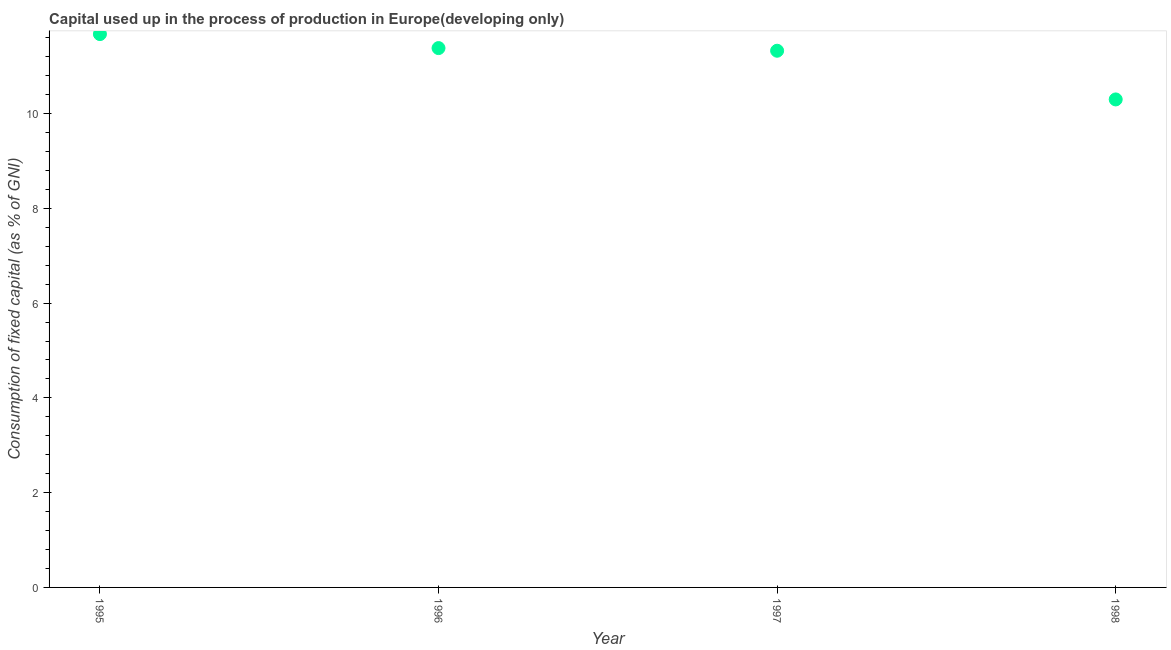What is the consumption of fixed capital in 1997?
Keep it short and to the point. 11.33. Across all years, what is the maximum consumption of fixed capital?
Your answer should be compact. 11.68. Across all years, what is the minimum consumption of fixed capital?
Ensure brevity in your answer.  10.3. What is the sum of the consumption of fixed capital?
Give a very brief answer. 44.68. What is the difference between the consumption of fixed capital in 1997 and 1998?
Provide a short and direct response. 1.03. What is the average consumption of fixed capital per year?
Make the answer very short. 11.17. What is the median consumption of fixed capital?
Your answer should be compact. 11.35. Do a majority of the years between 1996 and 1995 (inclusive) have consumption of fixed capital greater than 0.8 %?
Offer a very short reply. No. What is the ratio of the consumption of fixed capital in 1996 to that in 1997?
Give a very brief answer. 1. Is the consumption of fixed capital in 1995 less than that in 1997?
Offer a terse response. No. What is the difference between the highest and the second highest consumption of fixed capital?
Your answer should be very brief. 0.3. Is the sum of the consumption of fixed capital in 1997 and 1998 greater than the maximum consumption of fixed capital across all years?
Provide a short and direct response. Yes. What is the difference between the highest and the lowest consumption of fixed capital?
Your answer should be compact. 1.38. In how many years, is the consumption of fixed capital greater than the average consumption of fixed capital taken over all years?
Your answer should be very brief. 3. Does the consumption of fixed capital monotonically increase over the years?
Your answer should be compact. No. Does the graph contain any zero values?
Provide a succinct answer. No. What is the title of the graph?
Make the answer very short. Capital used up in the process of production in Europe(developing only). What is the label or title of the X-axis?
Make the answer very short. Year. What is the label or title of the Y-axis?
Keep it short and to the point. Consumption of fixed capital (as % of GNI). What is the Consumption of fixed capital (as % of GNI) in 1995?
Offer a terse response. 11.68. What is the Consumption of fixed capital (as % of GNI) in 1996?
Keep it short and to the point. 11.38. What is the Consumption of fixed capital (as % of GNI) in 1997?
Your answer should be compact. 11.33. What is the Consumption of fixed capital (as % of GNI) in 1998?
Give a very brief answer. 10.3. What is the difference between the Consumption of fixed capital (as % of GNI) in 1995 and 1996?
Ensure brevity in your answer.  0.3. What is the difference between the Consumption of fixed capital (as % of GNI) in 1995 and 1997?
Offer a very short reply. 0.35. What is the difference between the Consumption of fixed capital (as % of GNI) in 1995 and 1998?
Ensure brevity in your answer.  1.38. What is the difference between the Consumption of fixed capital (as % of GNI) in 1996 and 1997?
Offer a very short reply. 0.06. What is the difference between the Consumption of fixed capital (as % of GNI) in 1996 and 1998?
Ensure brevity in your answer.  1.08. What is the difference between the Consumption of fixed capital (as % of GNI) in 1997 and 1998?
Keep it short and to the point. 1.03. What is the ratio of the Consumption of fixed capital (as % of GNI) in 1995 to that in 1996?
Make the answer very short. 1.03. What is the ratio of the Consumption of fixed capital (as % of GNI) in 1995 to that in 1997?
Give a very brief answer. 1.03. What is the ratio of the Consumption of fixed capital (as % of GNI) in 1995 to that in 1998?
Offer a terse response. 1.13. What is the ratio of the Consumption of fixed capital (as % of GNI) in 1996 to that in 1997?
Provide a short and direct response. 1. What is the ratio of the Consumption of fixed capital (as % of GNI) in 1996 to that in 1998?
Provide a succinct answer. 1.1. 